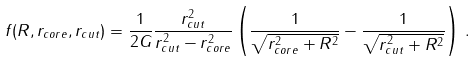Convert formula to latex. <formula><loc_0><loc_0><loc_500><loc_500>f ( R , r _ { c o r e } , r _ { c u t } ) = \frac { 1 } { 2 G } \frac { r _ { c u t } ^ { 2 } } { r _ { c u t } ^ { 2 } - r _ { c o r e } ^ { 2 } } \left ( \frac { 1 } { \sqrt { r _ { c o r e } ^ { 2 } + R ^ { 2 } } } - \frac { 1 } { \sqrt { r _ { c u t } ^ { 2 } + R ^ { 2 } } } \right ) \, .</formula> 